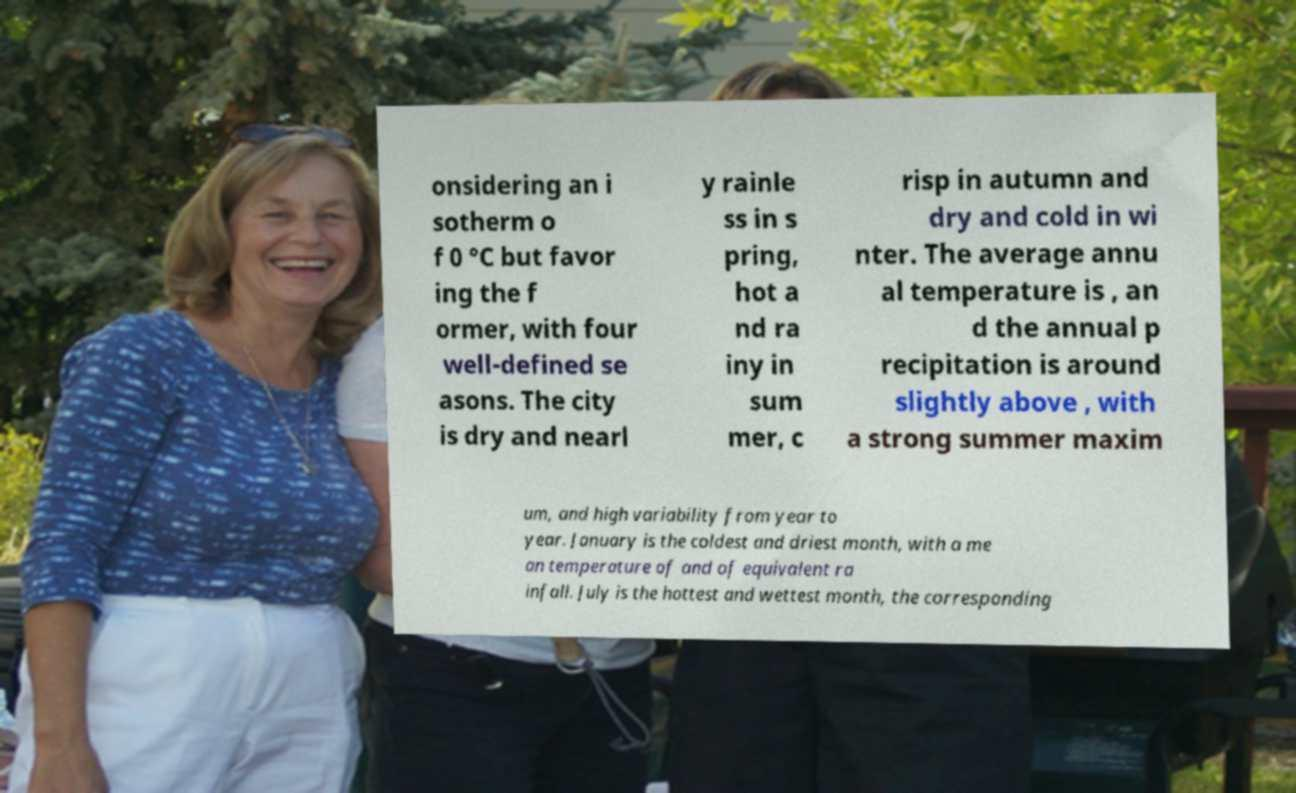For documentation purposes, I need the text within this image transcribed. Could you provide that? onsidering an i sotherm o f 0 °C but favor ing the f ormer, with four well-defined se asons. The city is dry and nearl y rainle ss in s pring, hot a nd ra iny in sum mer, c risp in autumn and dry and cold in wi nter. The average annu al temperature is , an d the annual p recipitation is around slightly above , with a strong summer maxim um, and high variability from year to year. January is the coldest and driest month, with a me an temperature of and of equivalent ra infall. July is the hottest and wettest month, the corresponding 